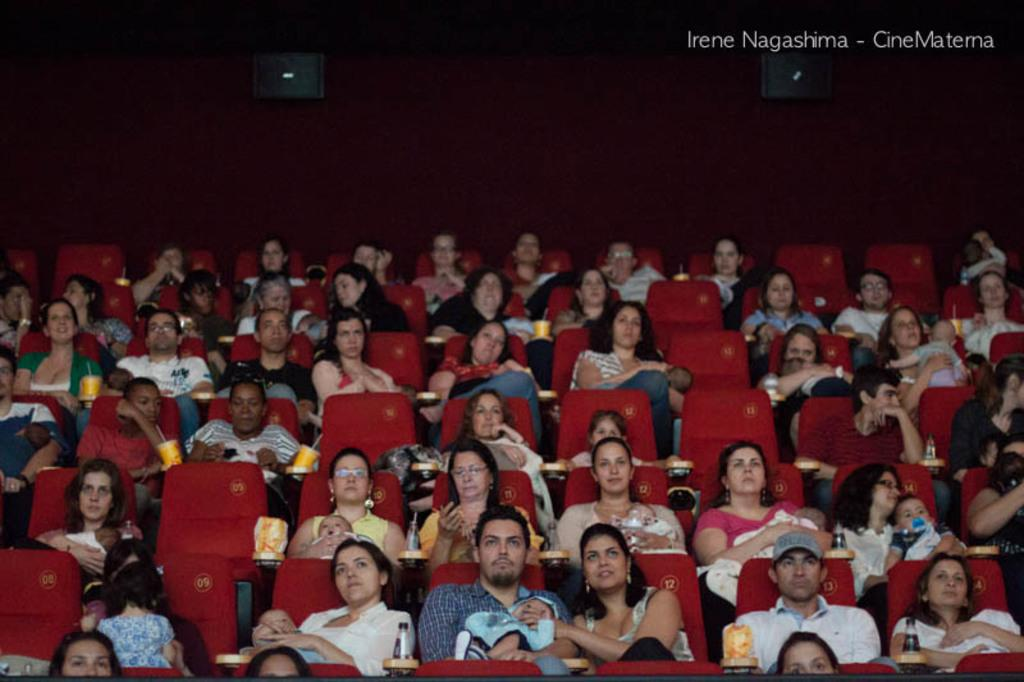What are the people in the image doing? The people in the image are sitting on chairs. What can be seen in the background of the image? There is a wall in the background of the image. What type of pet is sitting on the lap of the person in the image? There is no pet visible in the image; the people are sitting on chairs without any pets. 